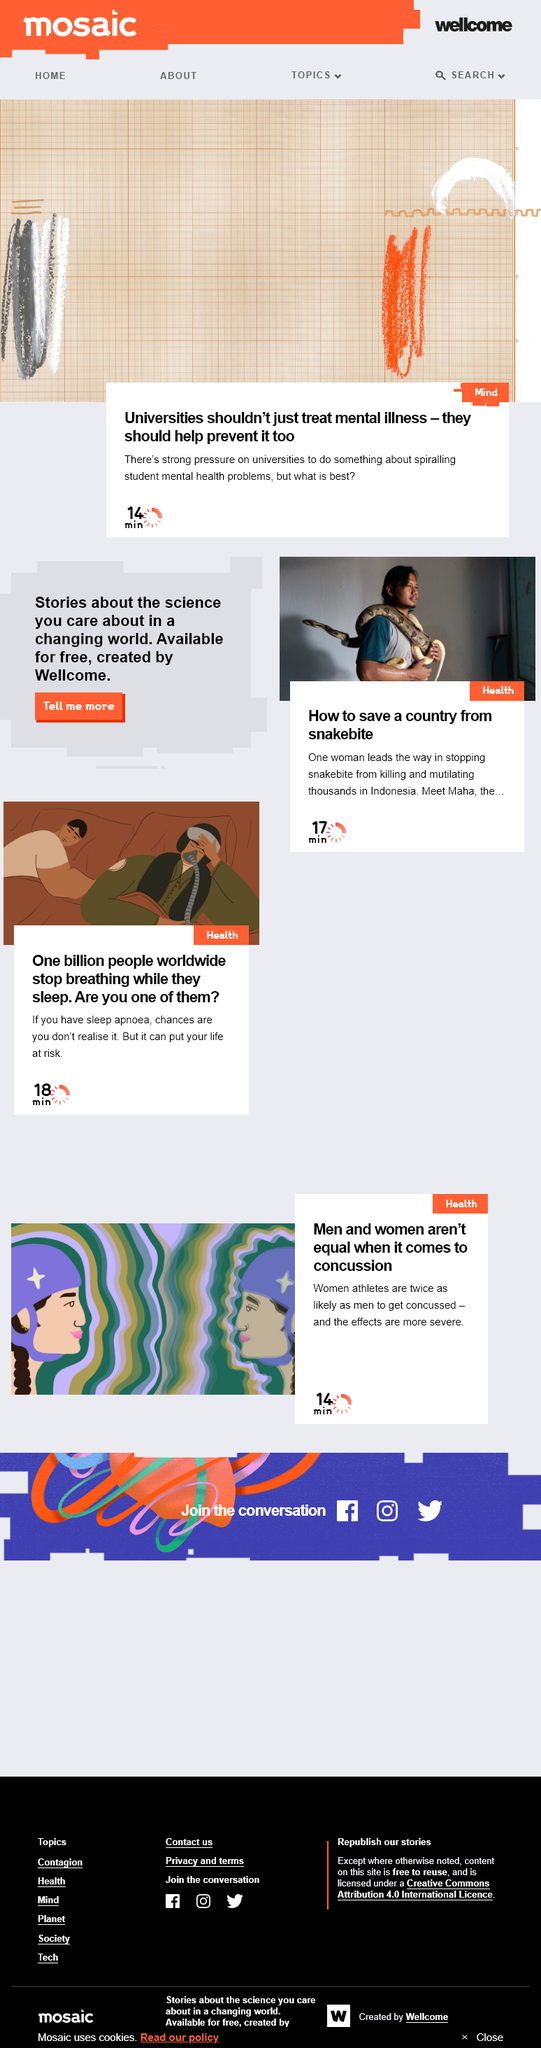Specify some key components in this picture. The woman named Maha leads the way in stopping snakebite from killing and mutilating thousands in Indonesia. It is estimated that one billion people worldwide are affected by sleep apnoea, a condition that causes brief interruptions in breathing while sleeping. There is a strong pressure on universities to take action in response to the escalating mental health issues affecting students. 